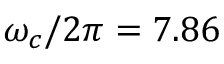Convert formula to latex. <formula><loc_0><loc_0><loc_500><loc_500>\omega _ { c } / 2 \pi = 7 . 8 6</formula> 